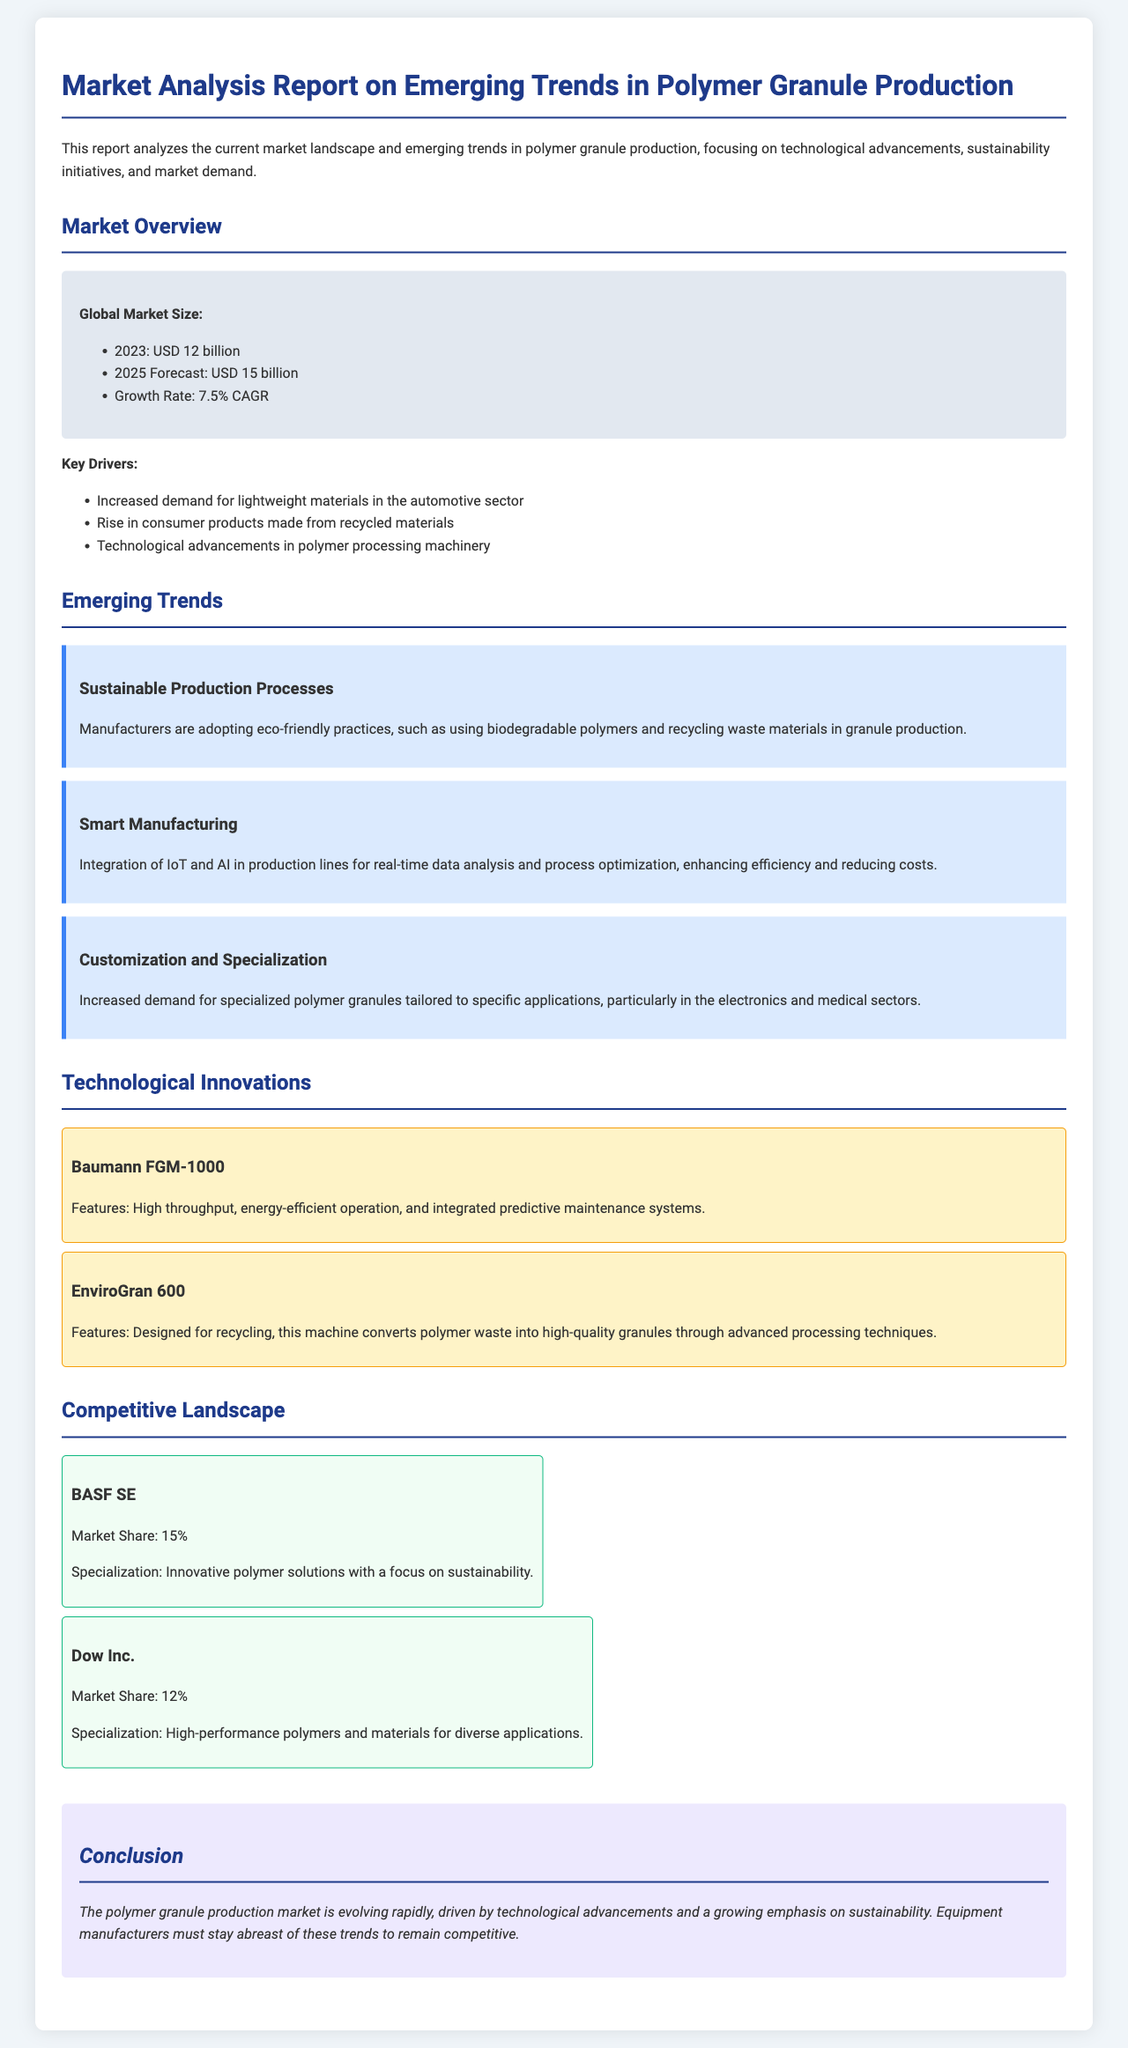what is the global market size for polymer granule production in 2023? The global market size for polymer granule production in 2023 is stated in the document as USD 12 billion.
Answer: USD 12 billion what is the forecasted market size for 2025? The document specifies that the forecasted market size for 2025 is USD 15 billion.
Answer: USD 15 billion what is the CAGR growth rate mentioned in the report? The report notes a growth rate of 7.5% CAGR for the polymer granule production market.
Answer: 7.5% CAGR what sustainable practice are manufacturers adopting? The report states that manufacturers are adopting eco-friendly practices, such as using biodegradable polymers and recycling waste materials.
Answer: eco-friendly practices which company has the largest market share? According to the document, BASF SE holds the largest market share at 15%.
Answer: BASF SE what technology is integrated into the Baumann FGM-1000 machine? The document mentions that the Baumann FGM-1000 features integrated predictive maintenance systems.
Answer: integrated predictive maintenance systems what is one of the key drivers in the market? The document lists increased demand for lightweight materials in the automotive sector as one of the key drivers.
Answer: lightweight materials in the automotive sector what trend is associated with customization and specialization? The report discusses increased demand for specialized polymer granules tailored to specific applications.
Answer: specialized polymer granules what is a major conclusion from the report? The report concludes that the polymer granule production market is evolving rapidly due to technological advancements and sustainability emphasis.
Answer: evolving rapidly 